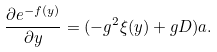Convert formula to latex. <formula><loc_0><loc_0><loc_500><loc_500>\frac { \partial e ^ { - f ( y ) } } { \partial y } = ( - g ^ { 2 } \xi ( y ) + g D ) a .</formula> 